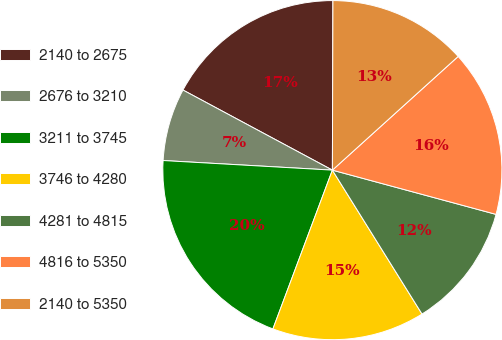<chart> <loc_0><loc_0><loc_500><loc_500><pie_chart><fcel>2140 to 2675<fcel>2676 to 3210<fcel>3211 to 3745<fcel>3746 to 4280<fcel>4281 to 4815<fcel>4816 to 5350<fcel>2140 to 5350<nl><fcel>17.22%<fcel>6.93%<fcel>20.2%<fcel>14.57%<fcel>11.93%<fcel>15.9%<fcel>13.25%<nl></chart> 